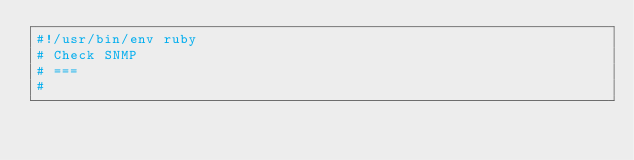<code> <loc_0><loc_0><loc_500><loc_500><_Ruby_>#!/usr/bin/env ruby
# Check SNMP
# ===
#</code> 